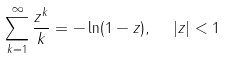<formula> <loc_0><loc_0><loc_500><loc_500>\sum _ { k = 1 } ^ { \infty } \frac { z ^ { k } } { k } = - \ln ( 1 - z ) , \ \ | z | < 1</formula> 